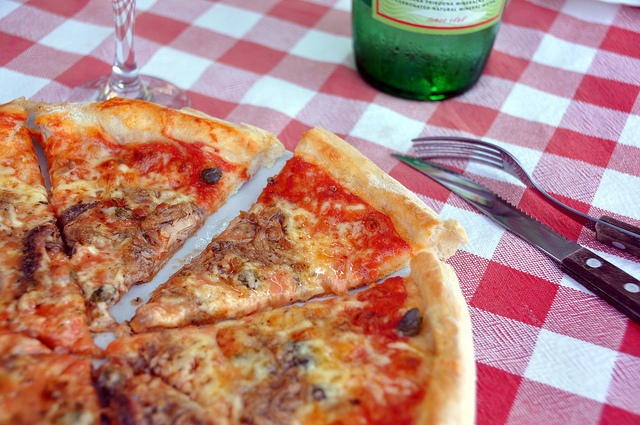<image>What eating utensils are needed for this food? It is unclear which eating utensils are needed for this food. It could be hands or a pizza cutter. What eating utensils are needed for this food? No eating utensils are needed for this food. It can be eaten with hands. 